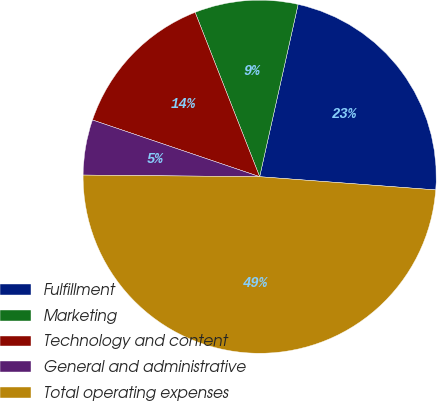Convert chart to OTSL. <chart><loc_0><loc_0><loc_500><loc_500><pie_chart><fcel>Fulfillment<fcel>Marketing<fcel>Technology and content<fcel>General and administrative<fcel>Total operating expenses<nl><fcel>22.7%<fcel>9.45%<fcel>13.84%<fcel>5.06%<fcel>48.96%<nl></chart> 